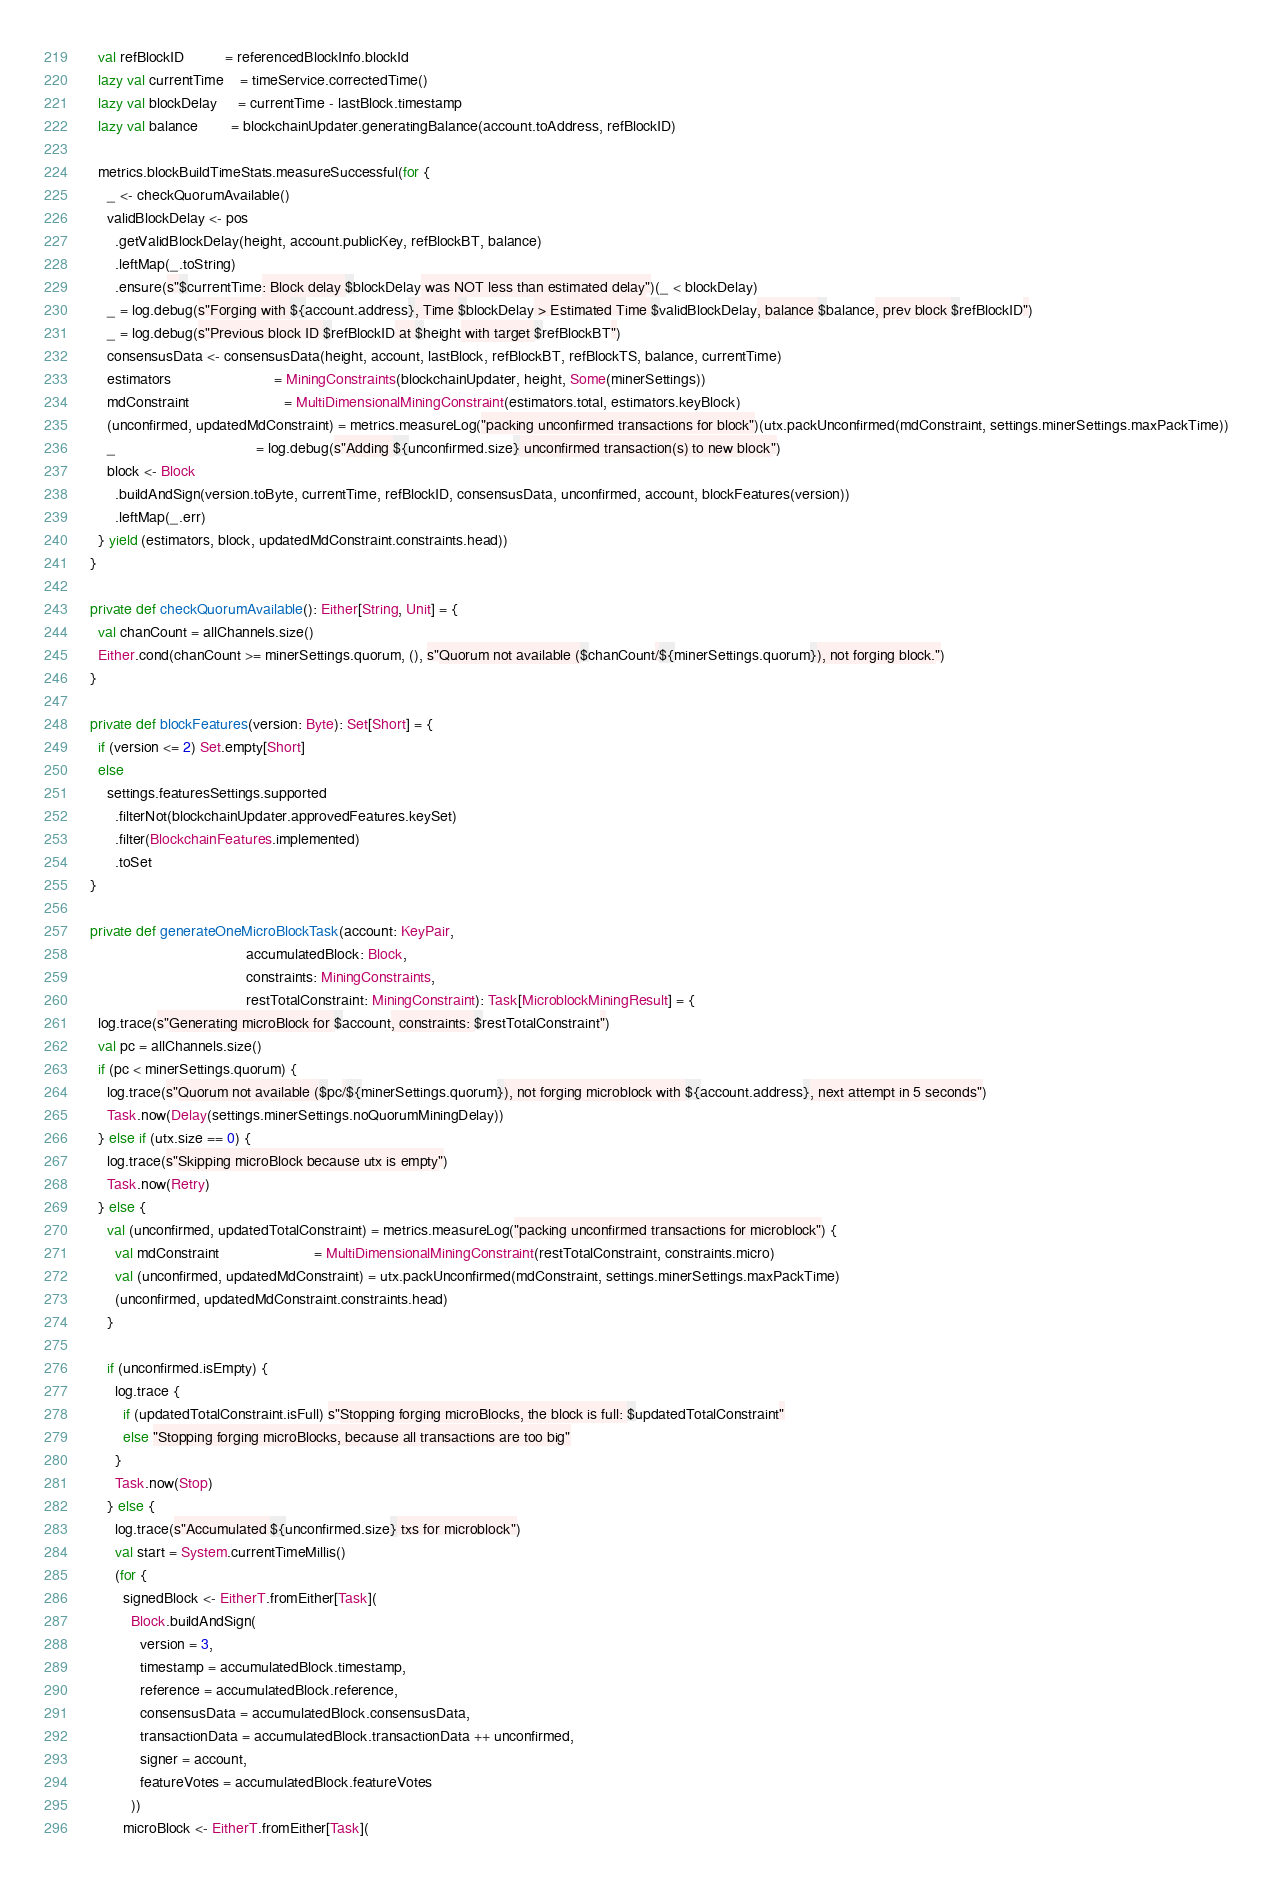Convert code to text. <code><loc_0><loc_0><loc_500><loc_500><_Scala_>    val refBlockID          = referencedBlockInfo.blockId
    lazy val currentTime    = timeService.correctedTime()
    lazy val blockDelay     = currentTime - lastBlock.timestamp
    lazy val balance        = blockchainUpdater.generatingBalance(account.toAddress, refBlockID)

    metrics.blockBuildTimeStats.measureSuccessful(for {
      _ <- checkQuorumAvailable()
      validBlockDelay <- pos
        .getValidBlockDelay(height, account.publicKey, refBlockBT, balance)
        .leftMap(_.toString)
        .ensure(s"$currentTime: Block delay $blockDelay was NOT less than estimated delay")(_ < blockDelay)
      _ = log.debug(s"Forging with ${account.address}, Time $blockDelay > Estimated Time $validBlockDelay, balance $balance, prev block $refBlockID")
      _ = log.debug(s"Previous block ID $refBlockID at $height with target $refBlockBT")
      consensusData <- consensusData(height, account, lastBlock, refBlockBT, refBlockTS, balance, currentTime)
      estimators                         = MiningConstraints(blockchainUpdater, height, Some(minerSettings))
      mdConstraint                       = MultiDimensionalMiningConstraint(estimators.total, estimators.keyBlock)
      (unconfirmed, updatedMdConstraint) = metrics.measureLog("packing unconfirmed transactions for block")(utx.packUnconfirmed(mdConstraint, settings.minerSettings.maxPackTime))
      _                                  = log.debug(s"Adding ${unconfirmed.size} unconfirmed transaction(s) to new block")
      block <- Block
        .buildAndSign(version.toByte, currentTime, refBlockID, consensusData, unconfirmed, account, blockFeatures(version))
        .leftMap(_.err)
    } yield (estimators, block, updatedMdConstraint.constraints.head))
  }

  private def checkQuorumAvailable(): Either[String, Unit] = {
    val chanCount = allChannels.size()
    Either.cond(chanCount >= minerSettings.quorum, (), s"Quorum not available ($chanCount/${minerSettings.quorum}), not forging block.")
  }

  private def blockFeatures(version: Byte): Set[Short] = {
    if (version <= 2) Set.empty[Short]
    else
      settings.featuresSettings.supported
        .filterNot(blockchainUpdater.approvedFeatures.keySet)
        .filter(BlockchainFeatures.implemented)
        .toSet
  }

  private def generateOneMicroBlockTask(account: KeyPair,
                                        accumulatedBlock: Block,
                                        constraints: MiningConstraints,
                                        restTotalConstraint: MiningConstraint): Task[MicroblockMiningResult] = {
    log.trace(s"Generating microBlock for $account, constraints: $restTotalConstraint")
    val pc = allChannels.size()
    if (pc < minerSettings.quorum) {
      log.trace(s"Quorum not available ($pc/${minerSettings.quorum}), not forging microblock with ${account.address}, next attempt in 5 seconds")
      Task.now(Delay(settings.minerSettings.noQuorumMiningDelay))
    } else if (utx.size == 0) {
      log.trace(s"Skipping microBlock because utx is empty")
      Task.now(Retry)
    } else {
      val (unconfirmed, updatedTotalConstraint) = metrics.measureLog("packing unconfirmed transactions for microblock") {
        val mdConstraint                       = MultiDimensionalMiningConstraint(restTotalConstraint, constraints.micro)
        val (unconfirmed, updatedMdConstraint) = utx.packUnconfirmed(mdConstraint, settings.minerSettings.maxPackTime)
        (unconfirmed, updatedMdConstraint.constraints.head)
      }

      if (unconfirmed.isEmpty) {
        log.trace {
          if (updatedTotalConstraint.isFull) s"Stopping forging microBlocks, the block is full: $updatedTotalConstraint"
          else "Stopping forging microBlocks, because all transactions are too big"
        }
        Task.now(Stop)
      } else {
        log.trace(s"Accumulated ${unconfirmed.size} txs for microblock")
        val start = System.currentTimeMillis()
        (for {
          signedBlock <- EitherT.fromEither[Task](
            Block.buildAndSign(
              version = 3,
              timestamp = accumulatedBlock.timestamp,
              reference = accumulatedBlock.reference,
              consensusData = accumulatedBlock.consensusData,
              transactionData = accumulatedBlock.transactionData ++ unconfirmed,
              signer = account,
              featureVotes = accumulatedBlock.featureVotes
            ))
          microBlock <- EitherT.fromEither[Task](</code> 